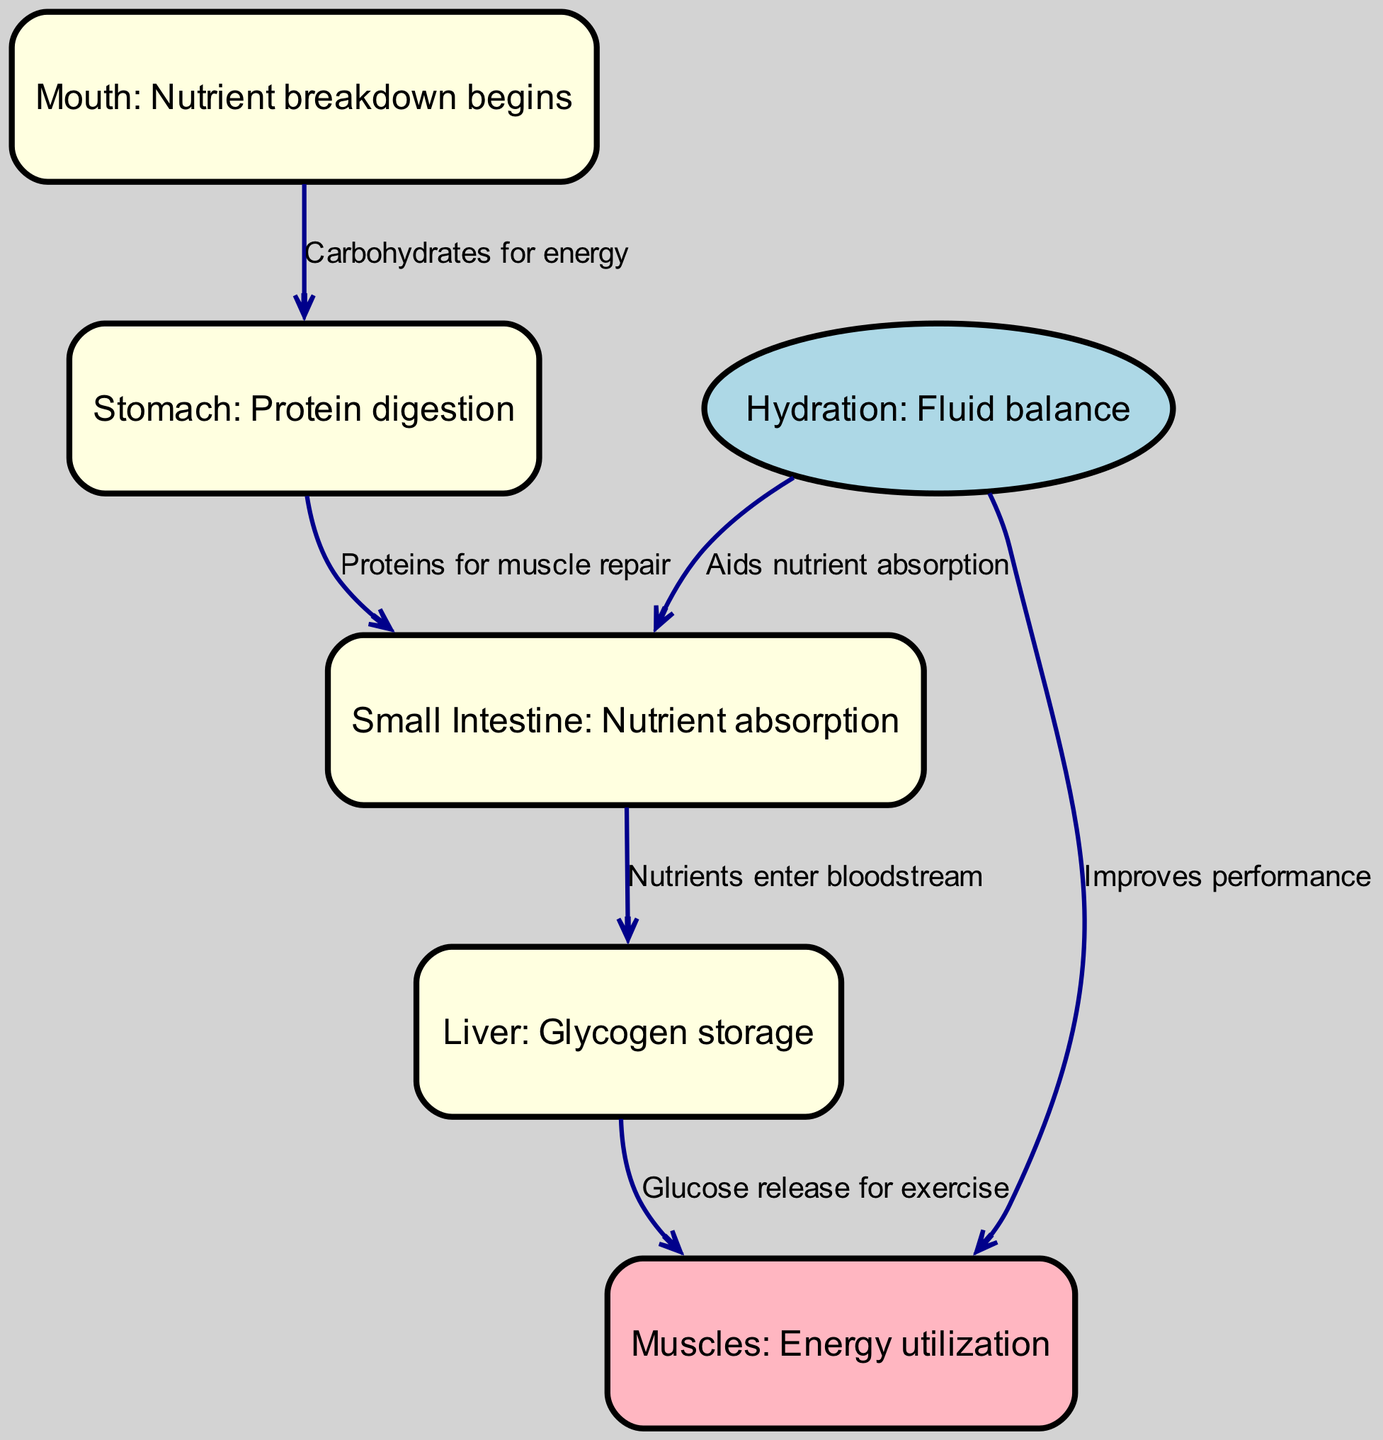What is the first step in nutrient breakdown? The diagram indicates that the first step in nutrient breakdown occurs in the mouth, which is labeled as "Mouth: Nutrient breakdown begins."
Answer: Mouth How many nodes are present in the diagram? By counting each unique node in the diagram, we find that there are a total of 6 nodes: mouth, stomach, small intestine, liver, muscles, and hydration.
Answer: 6 What nutrient is digested in the stomach? The diagram notes that in the stomach, "Protein digestion" takes place, specifically for the purpose of muscle repair.
Answer: Protein Which node is responsible for glycogen storage? The diagram identifies the liver as the organ responsible for glycogen storage, explicitly labeled as "Liver: Glycogen storage."
Answer: Liver What is the connection between hydration and muscles? The diagram indicates that hydration has a direct impact on muscles, where it "Improves performance," showcasing the importance of hydration for athletic performance.
Answer: Improves performance What is the flow of nutrients from the small intestine to the muscles? The flow of nutrients follows this path: first, nutrients exit the small intestine and enter the bloodstream, then they move from the liver to the muscles where glucose is released for exercise. This process is detailed in two connected edges in the diagram.
Answer: Nutrients enter bloodstream, then Glucose release for exercise How does hydration affect nutrient absorption? The diagram states that hydration "Aids nutrient absorption," showing that adequate hydration helps in the digestive process, specifically in the small intestine.
Answer: Aids nutrient absorption What is the relationship between the liver and muscles? According to the diagram, the liver releases glucose to the muscles, which is crucial for energy during exercise, indicating a direct relationship between these two nodes.
Answer: Glucose release for exercise 